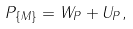Convert formula to latex. <formula><loc_0><loc_0><loc_500><loc_500>P _ { \{ M \} } = W _ { P } + U _ { P } ,</formula> 